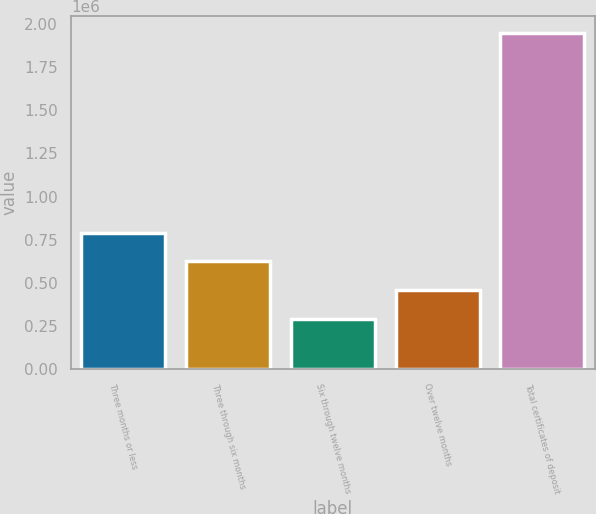Convert chart. <chart><loc_0><loc_0><loc_500><loc_500><bar_chart><fcel>Three months or less<fcel>Three through six months<fcel>Six through twelve months<fcel>Over twelve months<fcel>Total certificates of deposit<nl><fcel>790062<fcel>624177<fcel>287593<fcel>458292<fcel>1.94644e+06<nl></chart> 